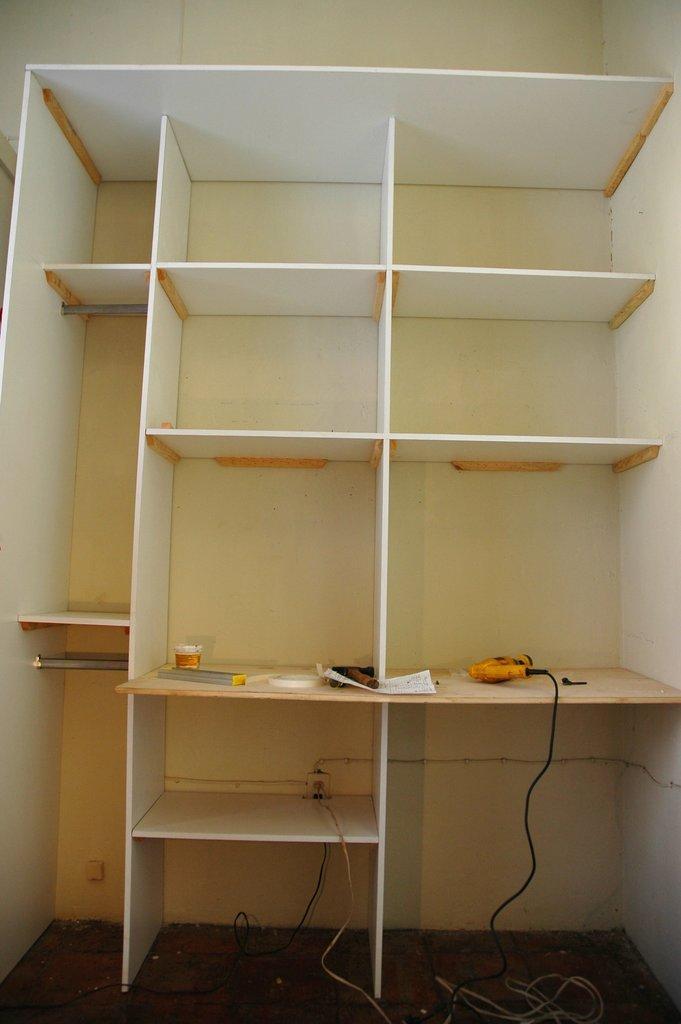Can you describe this image briefly? There is a cupboard with racks. On the cupboard there is a drill machine, hammer and many other items. 